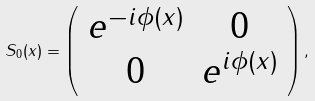Convert formula to latex. <formula><loc_0><loc_0><loc_500><loc_500>S _ { 0 } ( x ) = \left ( \begin{array} { c c } e ^ { - i \phi ( x ) } & 0 \\ 0 & e ^ { i \phi ( x ) } \end{array} \right ) ,</formula> 